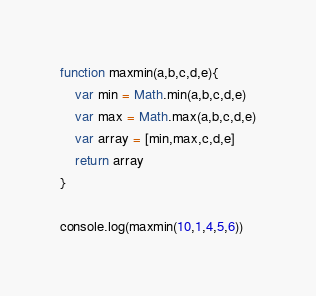Convert code to text. <code><loc_0><loc_0><loc_500><loc_500><_JavaScript_>function maxmin(a,b,c,d,e){
    var min = Math.min(a,b,c,d,e)
    var max = Math.max(a,b,c,d,e)
    var array = [min,max,c,d,e] 
    return array   
}

console.log(maxmin(10,1,4,5,6))</code> 